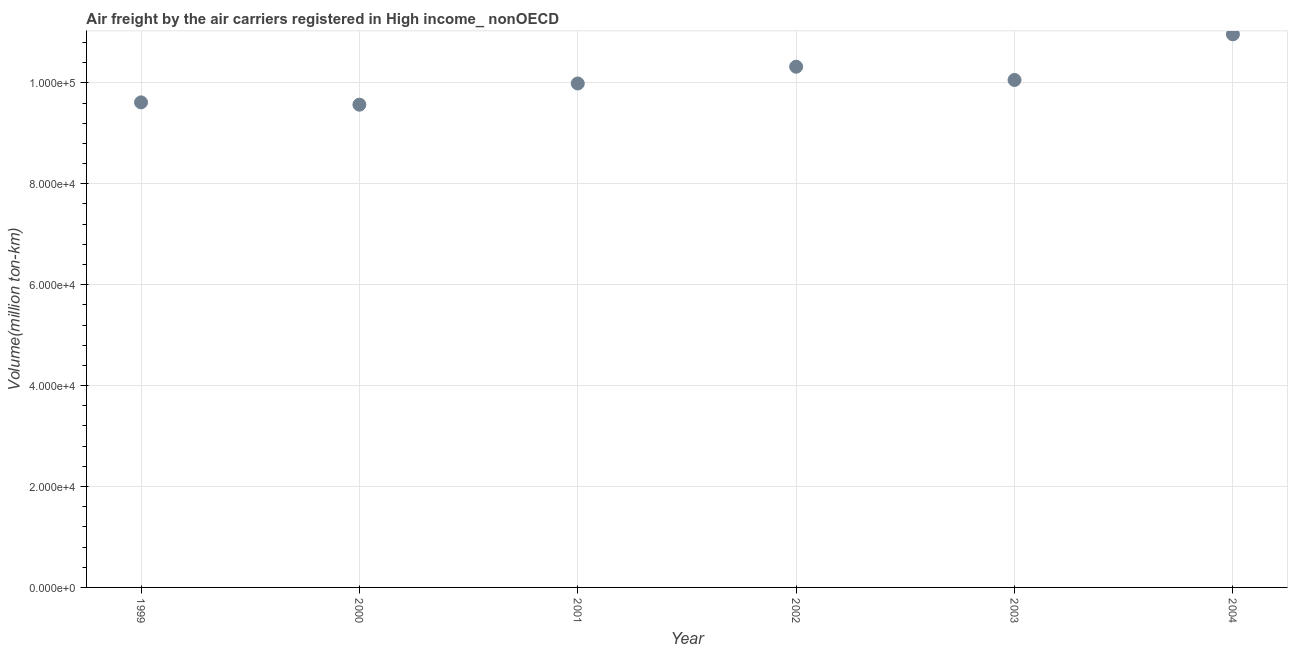What is the air freight in 2000?
Your response must be concise. 9.57e+04. Across all years, what is the maximum air freight?
Ensure brevity in your answer.  1.10e+05. Across all years, what is the minimum air freight?
Ensure brevity in your answer.  9.57e+04. In which year was the air freight maximum?
Your response must be concise. 2004. What is the sum of the air freight?
Keep it short and to the point. 6.05e+05. What is the difference between the air freight in 1999 and 2000?
Your response must be concise. 456.04. What is the average air freight per year?
Offer a terse response. 1.01e+05. What is the median air freight?
Provide a succinct answer. 1.00e+05. What is the ratio of the air freight in 2001 to that in 2002?
Provide a short and direct response. 0.97. Is the air freight in 2001 less than that in 2004?
Provide a short and direct response. Yes. Is the difference between the air freight in 2000 and 2002 greater than the difference between any two years?
Provide a short and direct response. No. What is the difference between the highest and the second highest air freight?
Provide a succinct answer. 6418.12. What is the difference between the highest and the lowest air freight?
Provide a succinct answer. 1.39e+04. Does the air freight monotonically increase over the years?
Ensure brevity in your answer.  No. How many dotlines are there?
Make the answer very short. 1. How many years are there in the graph?
Provide a succinct answer. 6. Are the values on the major ticks of Y-axis written in scientific E-notation?
Your answer should be compact. Yes. What is the title of the graph?
Ensure brevity in your answer.  Air freight by the air carriers registered in High income_ nonOECD. What is the label or title of the X-axis?
Your answer should be compact. Year. What is the label or title of the Y-axis?
Provide a short and direct response. Volume(million ton-km). What is the Volume(million ton-km) in 1999?
Your response must be concise. 9.61e+04. What is the Volume(million ton-km) in 2000?
Offer a very short reply. 9.57e+04. What is the Volume(million ton-km) in 2001?
Make the answer very short. 9.99e+04. What is the Volume(million ton-km) in 2002?
Keep it short and to the point. 1.03e+05. What is the Volume(million ton-km) in 2003?
Ensure brevity in your answer.  1.01e+05. What is the Volume(million ton-km) in 2004?
Your answer should be very brief. 1.10e+05. What is the difference between the Volume(million ton-km) in 1999 and 2000?
Your answer should be very brief. 456.04. What is the difference between the Volume(million ton-km) in 1999 and 2001?
Provide a short and direct response. -3746.63. What is the difference between the Volume(million ton-km) in 1999 and 2002?
Make the answer very short. -7065.43. What is the difference between the Volume(million ton-km) in 1999 and 2003?
Make the answer very short. -4444.73. What is the difference between the Volume(million ton-km) in 1999 and 2004?
Keep it short and to the point. -1.35e+04. What is the difference between the Volume(million ton-km) in 2000 and 2001?
Make the answer very short. -4202.68. What is the difference between the Volume(million ton-km) in 2000 and 2002?
Offer a very short reply. -7521.47. What is the difference between the Volume(million ton-km) in 2000 and 2003?
Keep it short and to the point. -4900.77. What is the difference between the Volume(million ton-km) in 2000 and 2004?
Your answer should be compact. -1.39e+04. What is the difference between the Volume(million ton-km) in 2001 and 2002?
Give a very brief answer. -3318.79. What is the difference between the Volume(million ton-km) in 2001 and 2003?
Ensure brevity in your answer.  -698.1. What is the difference between the Volume(million ton-km) in 2001 and 2004?
Your answer should be compact. -9736.91. What is the difference between the Volume(million ton-km) in 2002 and 2003?
Provide a short and direct response. 2620.7. What is the difference between the Volume(million ton-km) in 2002 and 2004?
Ensure brevity in your answer.  -6418.12. What is the difference between the Volume(million ton-km) in 2003 and 2004?
Give a very brief answer. -9038.82. What is the ratio of the Volume(million ton-km) in 1999 to that in 2002?
Provide a short and direct response. 0.93. What is the ratio of the Volume(million ton-km) in 1999 to that in 2003?
Offer a very short reply. 0.96. What is the ratio of the Volume(million ton-km) in 1999 to that in 2004?
Ensure brevity in your answer.  0.88. What is the ratio of the Volume(million ton-km) in 2000 to that in 2001?
Keep it short and to the point. 0.96. What is the ratio of the Volume(million ton-km) in 2000 to that in 2002?
Provide a succinct answer. 0.93. What is the ratio of the Volume(million ton-km) in 2000 to that in 2003?
Your response must be concise. 0.95. What is the ratio of the Volume(million ton-km) in 2000 to that in 2004?
Offer a very short reply. 0.87. What is the ratio of the Volume(million ton-km) in 2001 to that in 2004?
Offer a very short reply. 0.91. What is the ratio of the Volume(million ton-km) in 2002 to that in 2004?
Offer a terse response. 0.94. What is the ratio of the Volume(million ton-km) in 2003 to that in 2004?
Your answer should be compact. 0.92. 